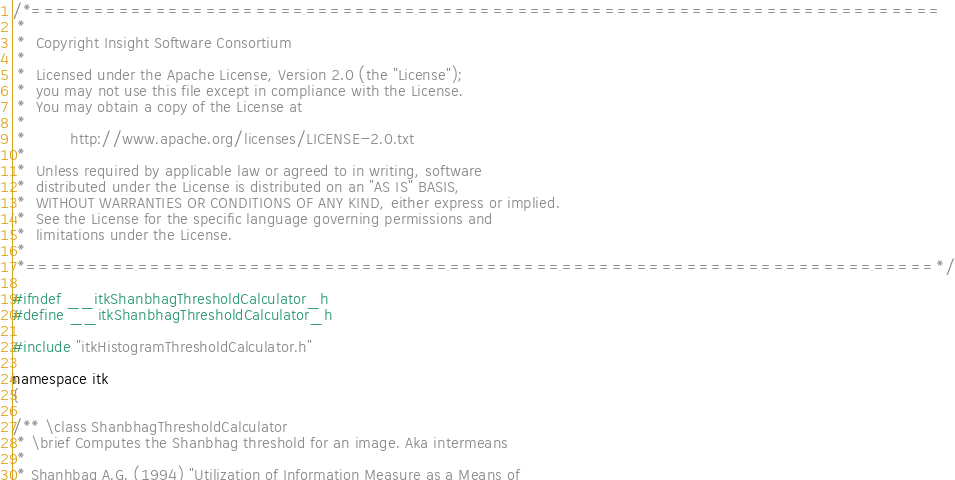<code> <loc_0><loc_0><loc_500><loc_500><_C_>/*=========================================================================
 *
 *  Copyright Insight Software Consortium
 *
 *  Licensed under the Apache License, Version 2.0 (the "License");
 *  you may not use this file except in compliance with the License.
 *  You may obtain a copy of the License at
 *
 *         http://www.apache.org/licenses/LICENSE-2.0.txt
 *
 *  Unless required by applicable law or agreed to in writing, software
 *  distributed under the License is distributed on an "AS IS" BASIS,
 *  WITHOUT WARRANTIES OR CONDITIONS OF ANY KIND, either express or implied.
 *  See the License for the specific language governing permissions and
 *  limitations under the License.
 *
 *=========================================================================*/

#ifndef __itkShanbhagThresholdCalculator_h
#define __itkShanbhagThresholdCalculator_h

#include "itkHistogramThresholdCalculator.h"

namespace itk
{

/** \class ShanbhagThresholdCalculator
 * \brief Computes the Shanbhag threshold for an image. Aka intermeans
 *
 * Shanhbag A.G. (1994) "Utilization of Information Measure as a Means of</code> 